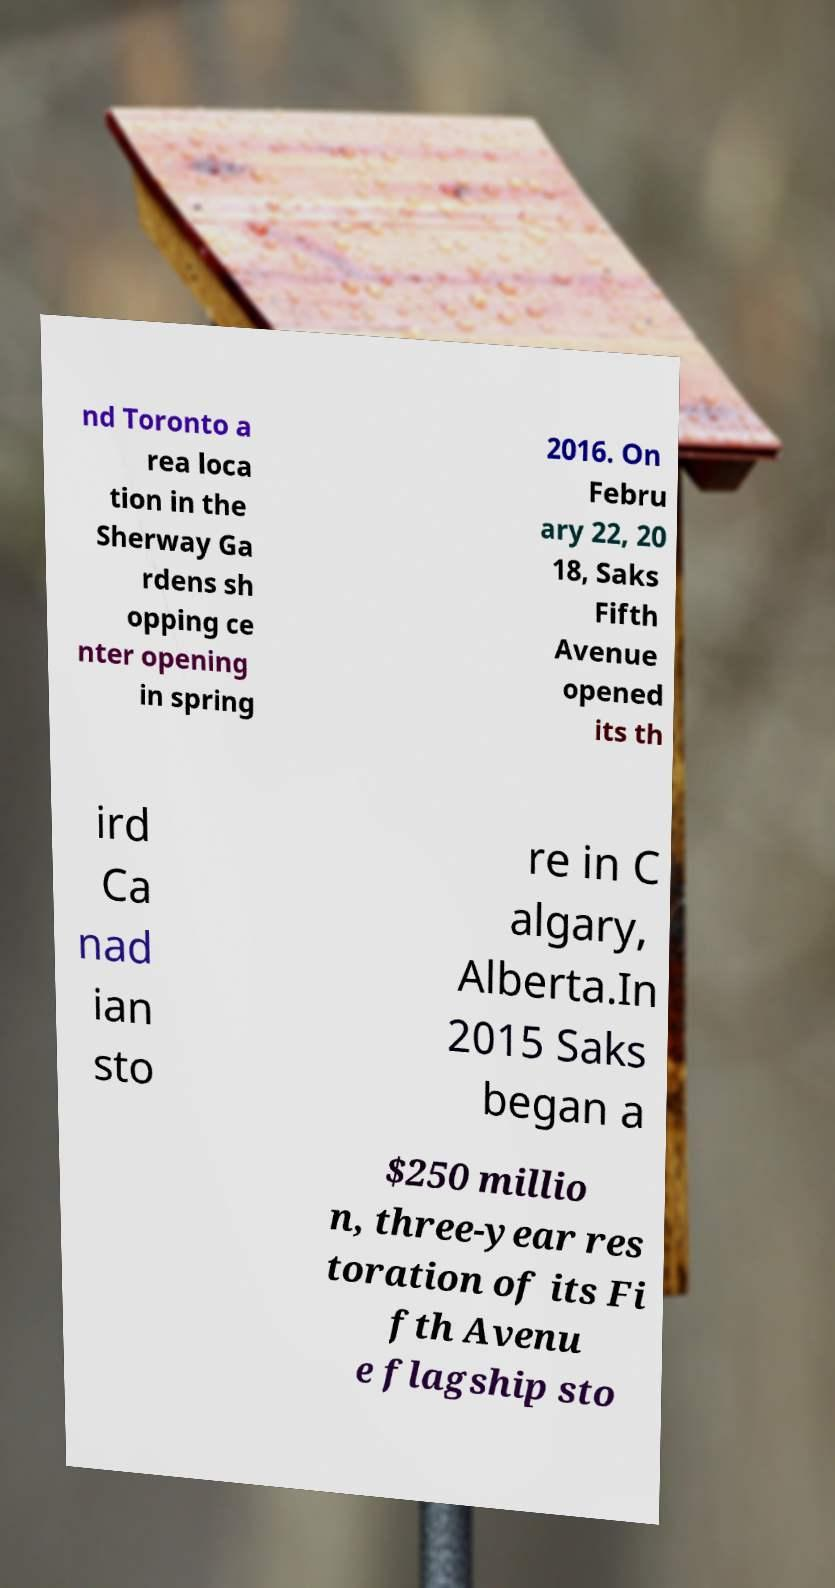For documentation purposes, I need the text within this image transcribed. Could you provide that? nd Toronto a rea loca tion in the Sherway Ga rdens sh opping ce nter opening in spring 2016. On Febru ary 22, 20 18, Saks Fifth Avenue opened its th ird Ca nad ian sto re in C algary, Alberta.In 2015 Saks began a $250 millio n, three-year res toration of its Fi fth Avenu e flagship sto 